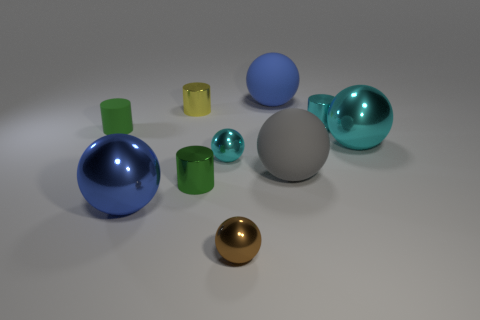Subtract all cyan shiny cylinders. How many cylinders are left? 3 Subtract all brown balls. How many balls are left? 5 Subtract 3 cylinders. How many cylinders are left? 1 Add 5 big balls. How many big balls exist? 9 Subtract 2 blue spheres. How many objects are left? 8 Subtract all spheres. How many objects are left? 4 Subtract all green balls. Subtract all red cubes. How many balls are left? 6 Subtract all brown blocks. How many red spheres are left? 0 Subtract all metallic things. Subtract all large blue rubber blocks. How many objects are left? 3 Add 2 brown metallic things. How many brown metallic things are left? 3 